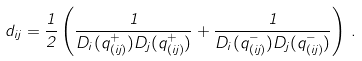Convert formula to latex. <formula><loc_0><loc_0><loc_500><loc_500>d _ { i j } = \frac { 1 } { 2 } \left ( \frac { 1 } { D _ { i } ( q ^ { + } _ { ( i j ) } ) D _ { j } ( q ^ { + } _ { ( i j ) } ) } + \frac { 1 } { D _ { i } ( q ^ { - } _ { ( i j ) } ) D _ { j } ( q ^ { - } _ { ( i j ) } ) } \right ) \, .</formula> 